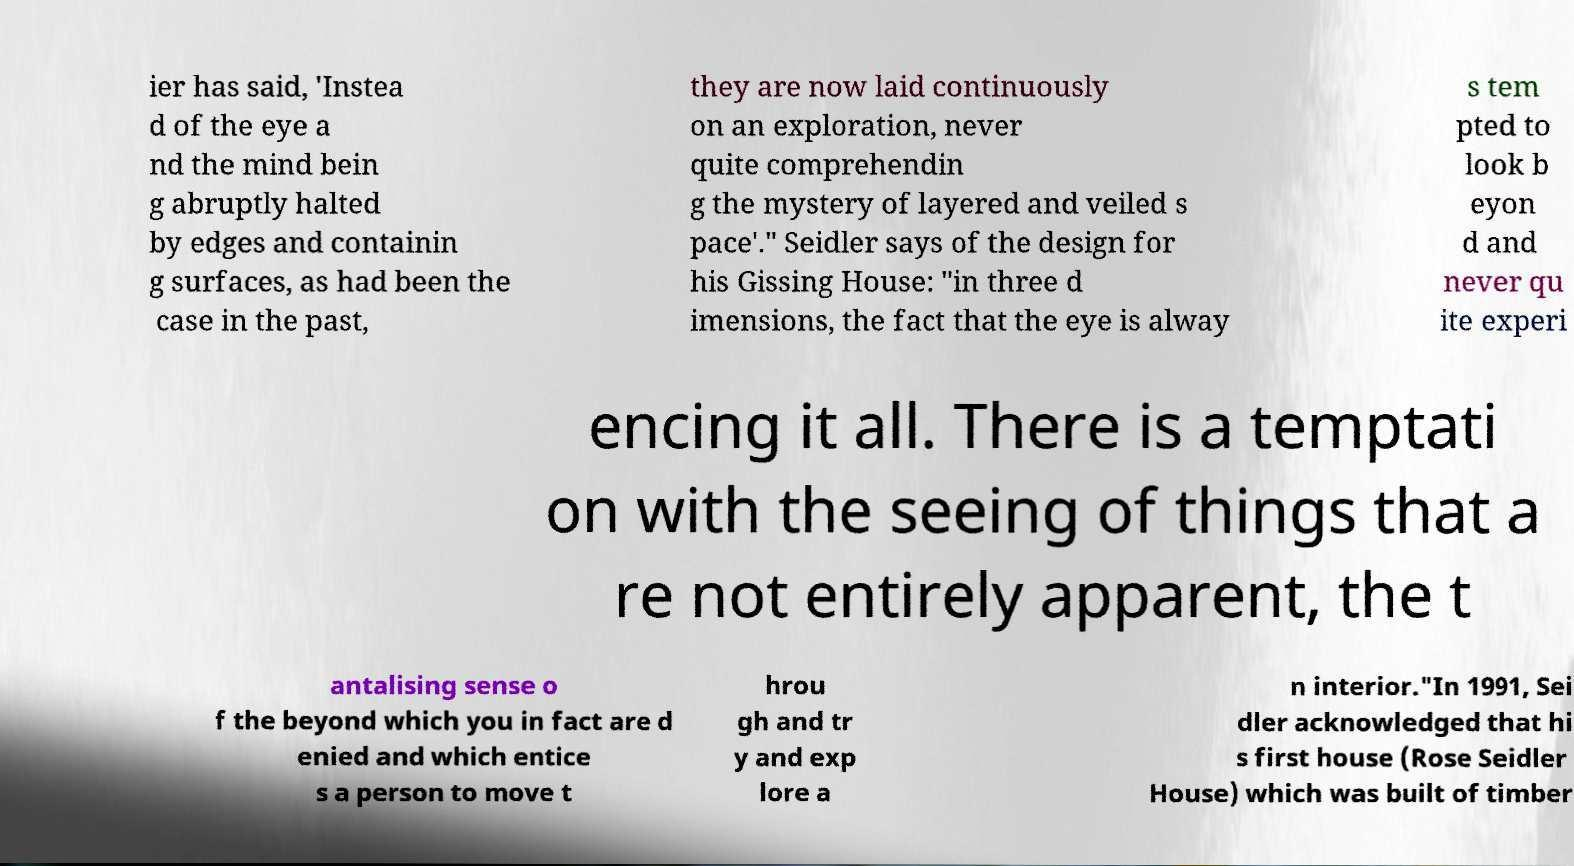Can you read and provide the text displayed in the image?This photo seems to have some interesting text. Can you extract and type it out for me? ier has said, 'Instea d of the eye a nd the mind bein g abruptly halted by edges and containin g surfaces, as had been the case in the past, they are now laid continuously on an exploration, never quite comprehendin g the mystery of layered and veiled s pace'." Seidler says of the design for his Gissing House: "in three d imensions, the fact that the eye is alway s tem pted to look b eyon d and never qu ite experi encing it all. There is a temptati on with the seeing of things that a re not entirely apparent, the t antalising sense o f the beyond which you in fact are d enied and which entice s a person to move t hrou gh and tr y and exp lore a n interior."In 1991, Sei dler acknowledged that hi s first house (Rose Seidler House) which was built of timber 